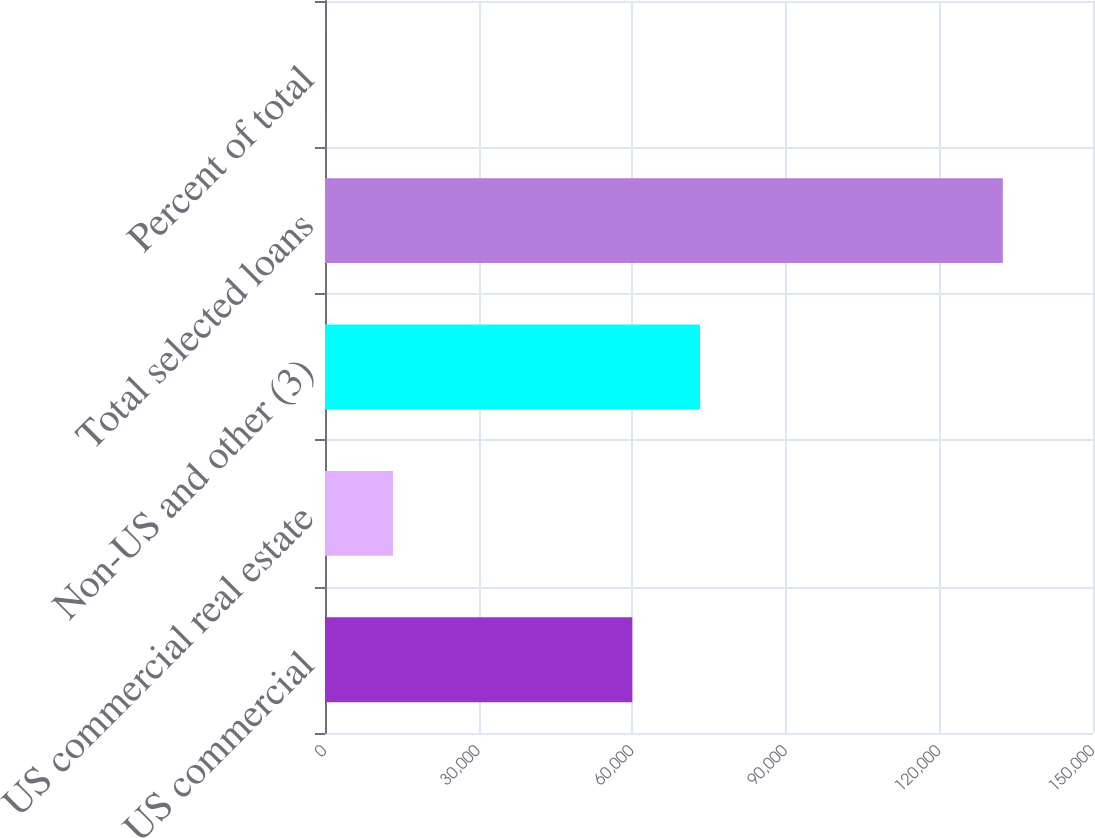Convert chart. <chart><loc_0><loc_0><loc_500><loc_500><bar_chart><fcel>US commercial<fcel>US commercial real estate<fcel>Non-US and other (3)<fcel>Total selected loans<fcel>Percent of total<nl><fcel>60018<fcel>13274.7<fcel>73252.7<fcel>132387<fcel>40<nl></chart> 